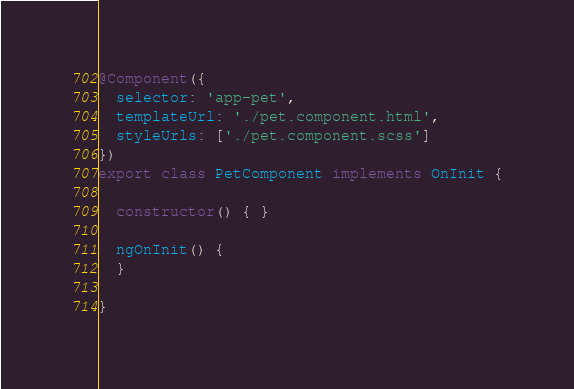<code> <loc_0><loc_0><loc_500><loc_500><_TypeScript_>
@Component({
  selector: 'app-pet',
  templateUrl: './pet.component.html',
  styleUrls: ['./pet.component.scss']
})
export class PetComponent implements OnInit {

  constructor() { }

  ngOnInit() {
  }

}
</code> 